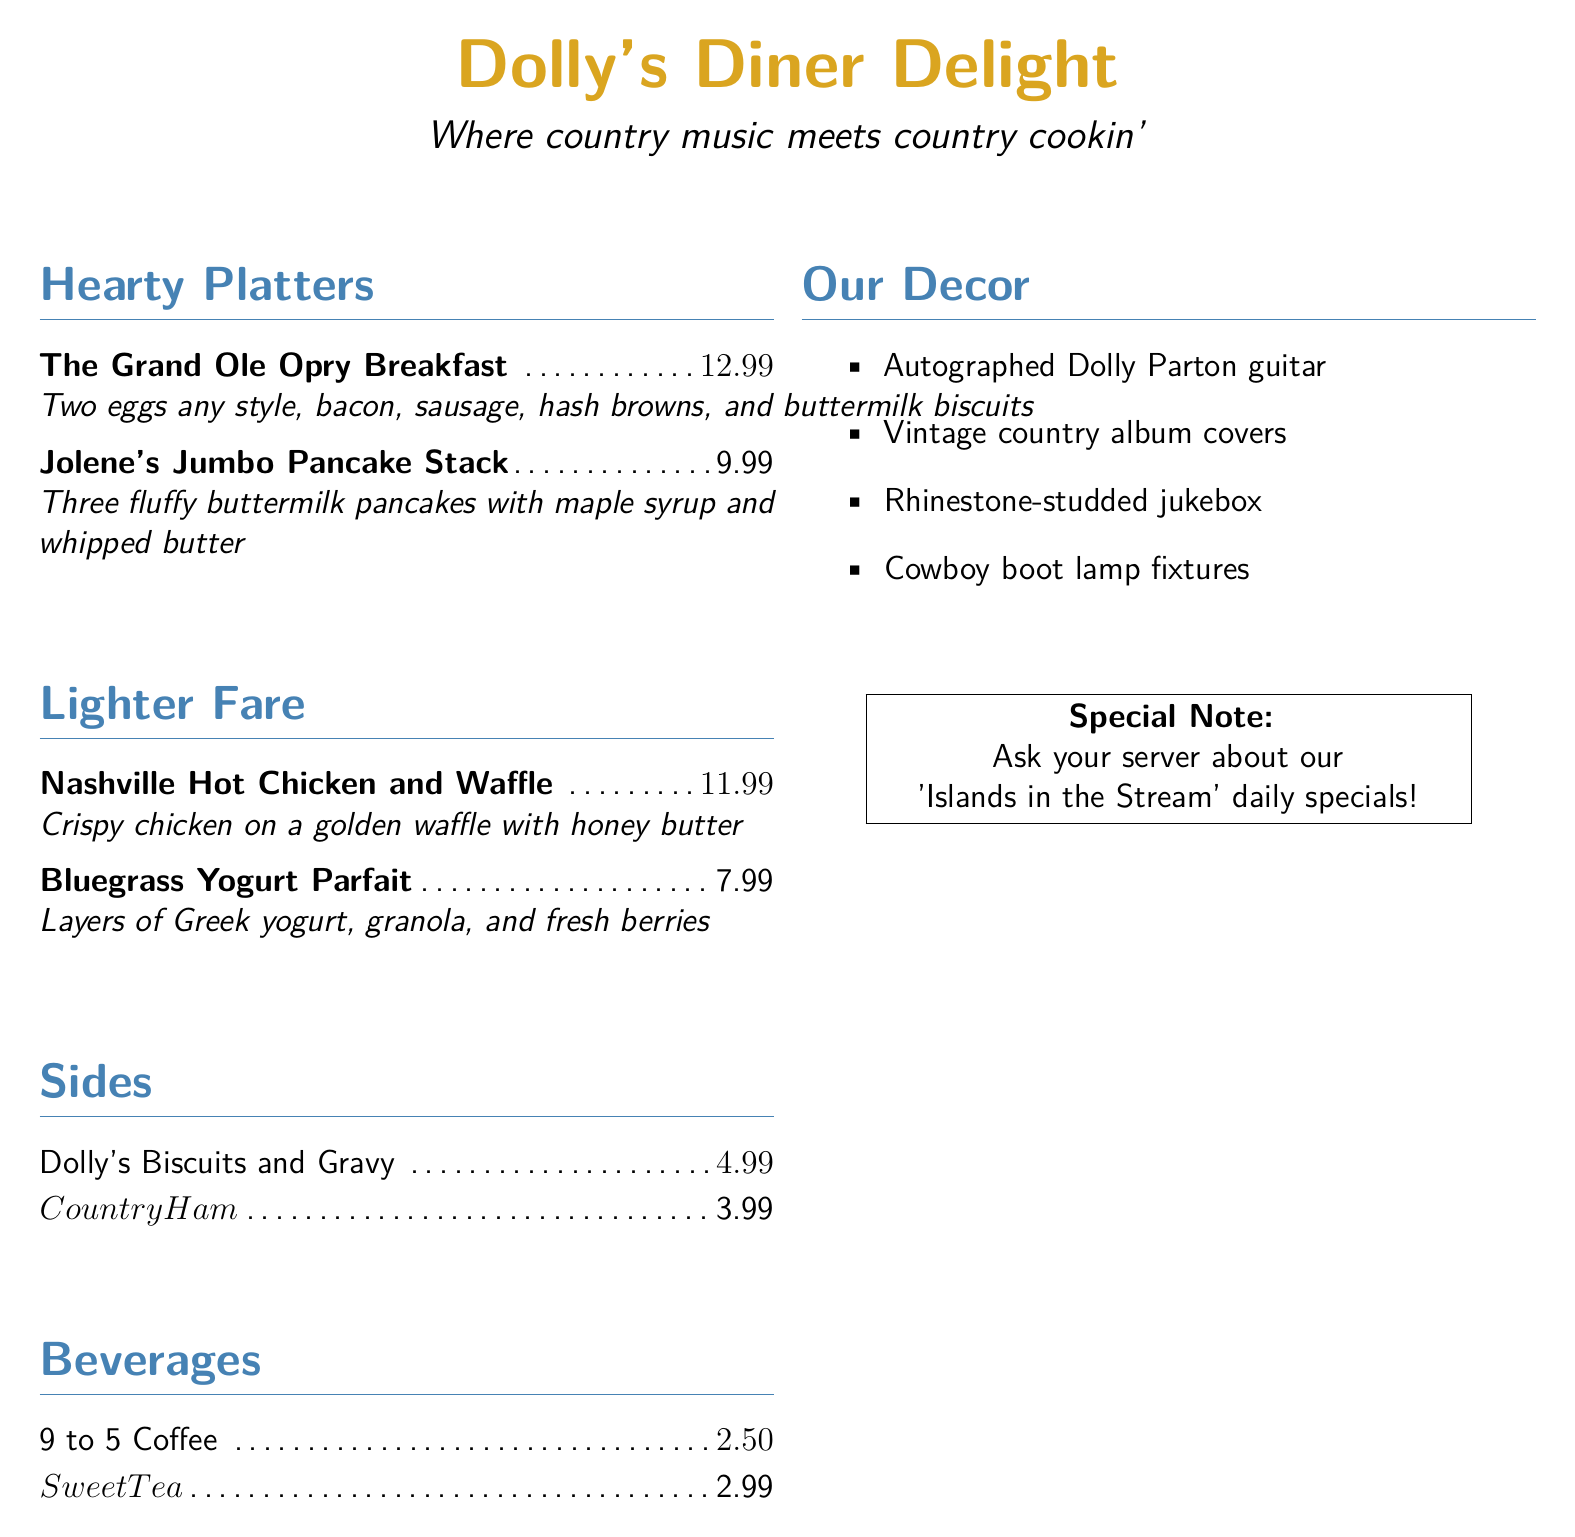What is the name of the diner? The name of the diner is listed at the top of the menu.
Answer: Dolly's Diner Delight What is the price of the Grand Ole Opry Breakfast? The price is specified next to the menu item in the hearty platters section.
Answer: $12.99 How many pancakes are in Jolene's Jumbo Pancake Stack? This information is found in the description of the pancake stack.
Answer: Three What side dish costs $3.99? The price is found next to the side dish in the menu.
Answer: Country Ham What beverage costs $2.50? This beverage price is indicated on the drink menu.
Answer: 9 to 5 Coffee What decor item is mentioned alongside Dolly Parton's memorabilia? The decor list includes various items found in the diner.
Answer: Autographed Dolly Parton guitar How much does the Nashville Hot Chicken and Waffle cost? The cost of this dish is stated in the lighter fare section.
Answer: $11.99 What special is mentioned at the bottom of the menu? This note informs customers about a unique feature of the diner.
Answer: 'Islands in the Stream' daily specials What type of lamp fixtures are mentioned in the decor section? The decor description specifies the type of fixtures used in the diner.
Answer: Cowboy boot lamp fixtures 